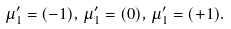Convert formula to latex. <formula><loc_0><loc_0><loc_500><loc_500>\mu ^ { \prime } _ { 1 } = ( - 1 ) , \, \mu ^ { \prime } _ { 1 } = ( 0 ) , \, \mu ^ { \prime } _ { 1 } = ( + 1 ) .</formula> 